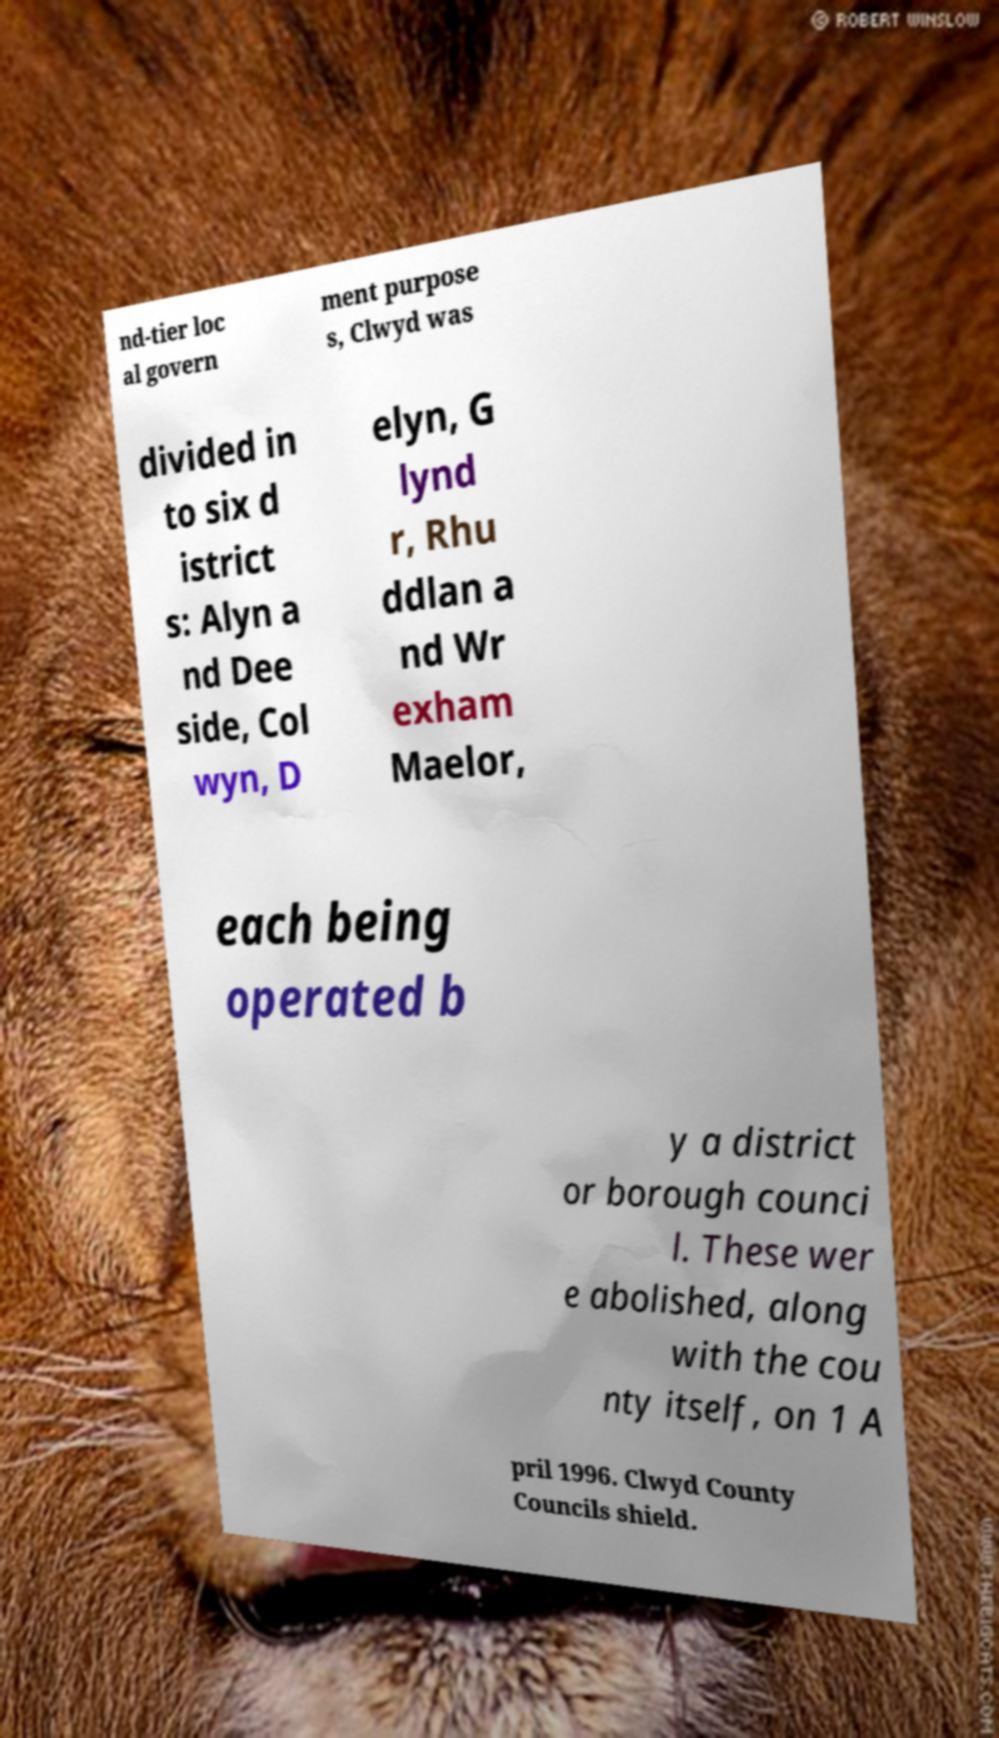I need the written content from this picture converted into text. Can you do that? nd-tier loc al govern ment purpose s, Clwyd was divided in to six d istrict s: Alyn a nd Dee side, Col wyn, D elyn, G lynd r, Rhu ddlan a nd Wr exham Maelor, each being operated b y a district or borough counci l. These wer e abolished, along with the cou nty itself, on 1 A pril 1996. Clwyd County Councils shield. 